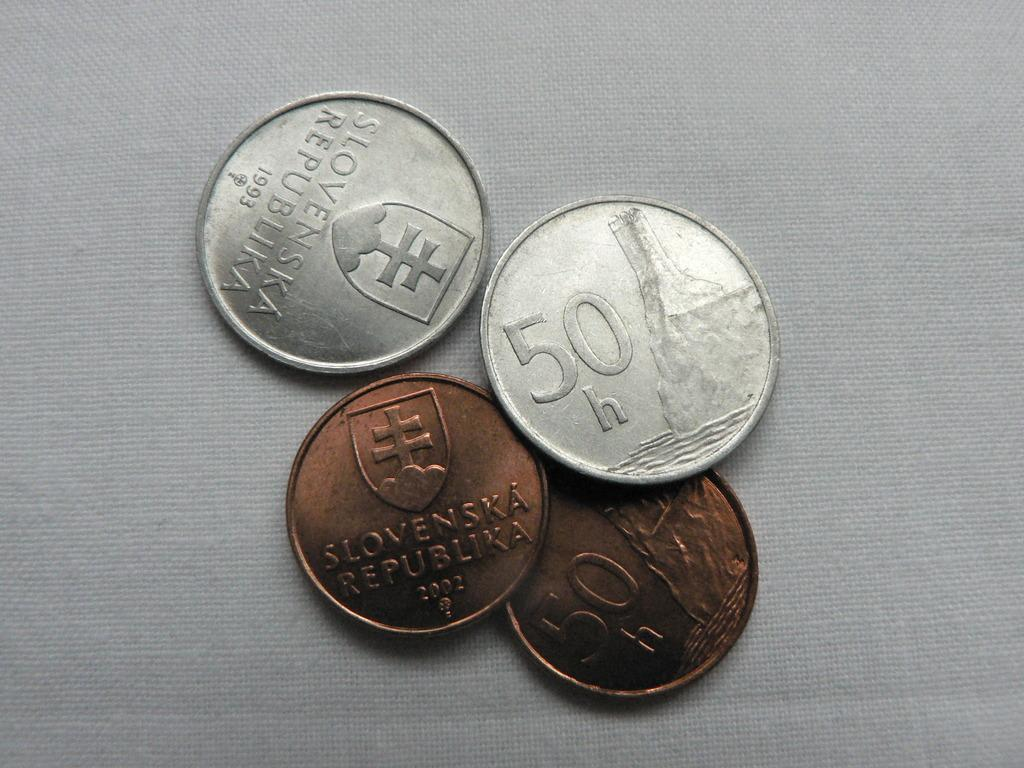<image>
Describe the image concisely. Two copper and 2 silver pieces of money from the Slovenska Republika. 